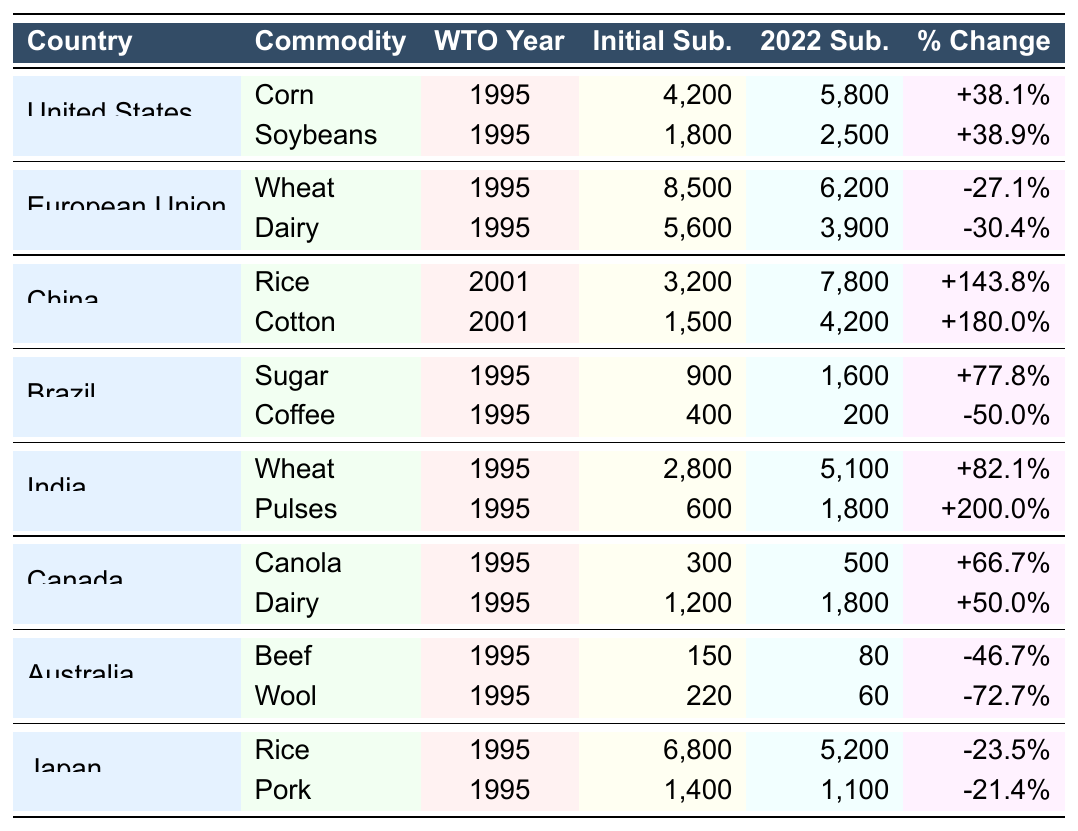What is the subsidy level for Corn in the United States in 2022? The table lists the subsidy level for Corn in the United States in 2022 as 5,800 million USD.
Answer: 5,800 million USD Which country had the highest percentage change in subsidies for Cotton? Looking at the percentage changes, China had the highest at +180.0% for Cotton.
Answer: China What was the subsidy level for Dairy in the European Union at accession? The table shows that the subsidy level for Dairy in the European Union at accession was 5,600 million USD.
Answer: 5,600 million USD Calculate the total initial subsidies for the agricultural commodities listed in Brazil. The initial subsidy levels for Brazil are 900 million USD for Sugar and 400 million USD for Coffee. So, total initial subsidies = 900 + 400 = 1,300 million USD.
Answer: 1,300 million USD Did Japan see an increase in subsidy levels for Rice since joining the WTO? The percentage change for Rice in Japan is -23.5%, indicating a decrease in subsidy levels since joining the WTO.
Answer: No What is the average subsidy level at accession across all listed countries? The total of initial subsidies is calculated as follows: 4,200 + 1,800 + 8,500 + 5,600 + 3,200 + 1,500 + 900 + 400 + 2,800 + 600 + 300 + 1,200 + 150 + 220 + 6,800 + 1,400 = 37,700 million USD. Since there are 16 entries, the average is 37,700/16 = 2,356.25 million USD.
Answer: 2,356.25 million USD Which commodity had the lowest subsidy level in 2022 among those listed? The lowest subsidy level in 2022 listed is for Beef in Australia at 80 million USD.
Answer: 80 million USD Is it true that all countries except China decreased their subsidy levels for key commodities since joining the WTO? In the table, China shows an increase in subsidies for both Rice and Cotton, while the majority of other countries have decreased their subsidy levels. Therefore, this statement is false.
Answer: False What was the total subsidy level for Pulses in India at accession and in 2022? The subsidy level for Pulses in India at accession was 600 million USD, and in 2022 it was 1,800 million USD; summing these gives 600 + 1,800 = 2,400 million USD.
Answer: 2,400 million USD Which agricultural commodity experienced a percentage decrease greater than 45% in Australia? The percentage decrease for Wool in Australia is -72.7%, which is greater than 45%.
Answer: Wool 